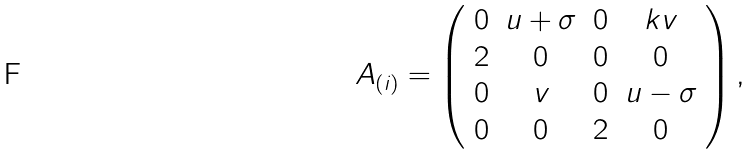Convert formula to latex. <formula><loc_0><loc_0><loc_500><loc_500>A _ { ( i ) } = \left ( \begin{array} { c c c c } 0 & u + \sigma & 0 & k v \\ 2 & 0 & 0 & 0 \\ 0 & v & 0 & u - \sigma \\ 0 & 0 & 2 & 0 \end{array} \right ) ,</formula> 